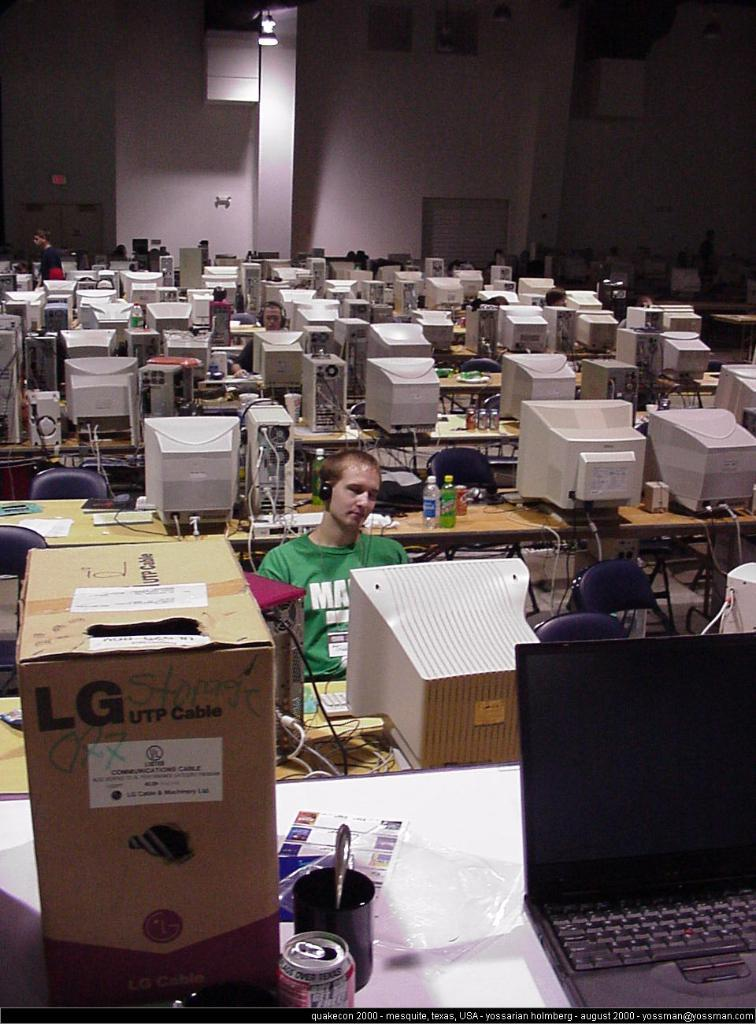Provide a one-sentence caption for the provided image. A row of computers with an LG box in the front. 